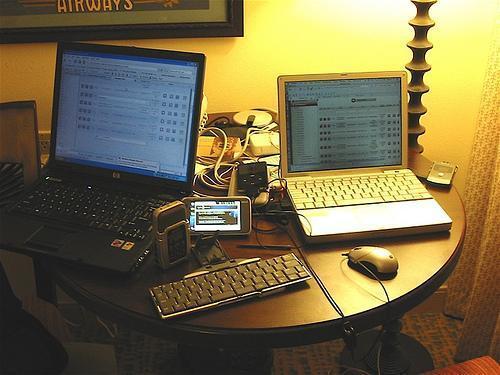How many laptops can be seen?
Give a very brief answer. 2. How many keyboards can you see?
Give a very brief answer. 3. How many giraffes are there?
Give a very brief answer. 0. 